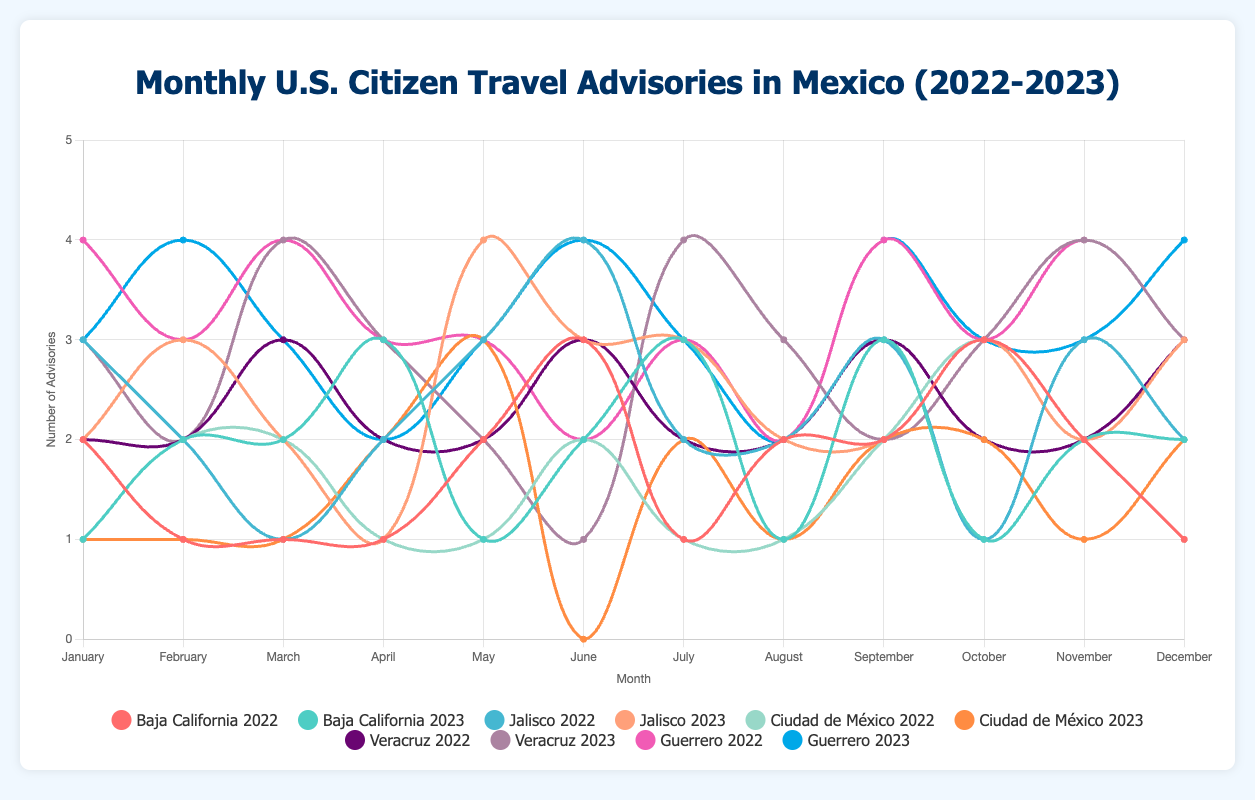Which region had the highest number of advisories in March 2023? In March 2023, Guerrero had the highest number of advisories with 3 advisories.
Answer: Guerrero How many months in 2023 did Jalisco have equal or more advisories than Baja California? For each month in 2023, compare the advisories for Jalisco and Baja California: February (Jalisco: 3, Baja California: 2), April (Jalisco: 1, Baja California: 3), May (Jalisco: 4, Baja California: 1), June (Jalisco: 3, Baja California: 2), July (Jalisco: 3, Baja California: 3), September (Jalisco: 2, Baja California: 3), October (Jalisco: 3, Baja California: 1), December (Jalisco: 3, Baja California: 2). In these months, Jalisco had equal/more advisories than Baja California.
Answer: 5 months In which month of 2022 did Baja California and Ciudad de México both have the same number of advisories, and what was that number? Check each month of 2022 for matching advisories in Baja California and Ciudad de México: January (Baja California: 2, Ciudad de México: 1), March (Both: 2 advisories), June (Both: 3 advisories), July (Both: 1 advisories). April and May(Baja California: 1, Ciudad de México: 2), August (Baja California: 2, Ciudad de México: 1), September (Baja California: 2, Ciudad de México: 2), October (Baja California: 3, Ciudad de México: 3), November (2), December (Baja California: 1, Ciudad de México: 1).
Answer: December, 1 What is the average number of advisories issued for Veracruz in 2022 and 2023? Sum the advisories for Veracruz in 2022 (2 + 2 + 3 + 2 + 2 + 3 + 2 + 2 + 3 + 2 + 2 + 3) = 28, and in 2023 (3 + 2 + 4 + 3 + 2 + 1 + 4 + 3 + 2 + 3 + 4 + 3) = 34. Add these sums and divide by the total number of months (28+34 = 62 divided by 24 months).
Answer: 2.58 Which region showed a significant drop in advisories from April to May 2023? Subtract the number of advisories in May 2023 from the number in April 2023 for each region. The significant drop was for Baja California from 3 to 1 advisories.
Answer: Baja California 